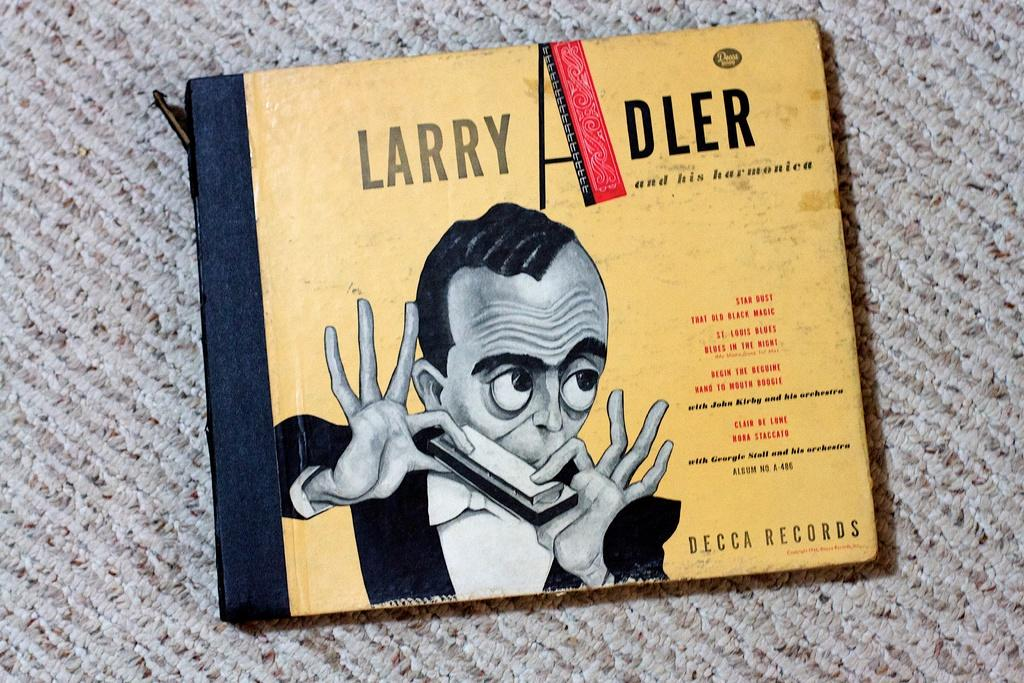What object is present in the image that is typically used for reading or learning? There is a book in the image. What can be seen on the cover of the book? A man is depicted on the book. What else can be seen on the book besides the man? Text is visible on the book. What is located at the bottom of the image? There is a floor mat at the bottom of the image. Where is the mailbox located in the image? There is no mailbox present in the image. What type of unit is the man on the book referring to? The image does not provide enough information to determine what type of unit the man on the book is referring to. 